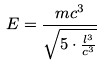<formula> <loc_0><loc_0><loc_500><loc_500>E = \frac { m c ^ { 3 } } { \sqrt { 5 \cdot \frac { l ^ { 3 } } { c ^ { 3 } } } }</formula> 